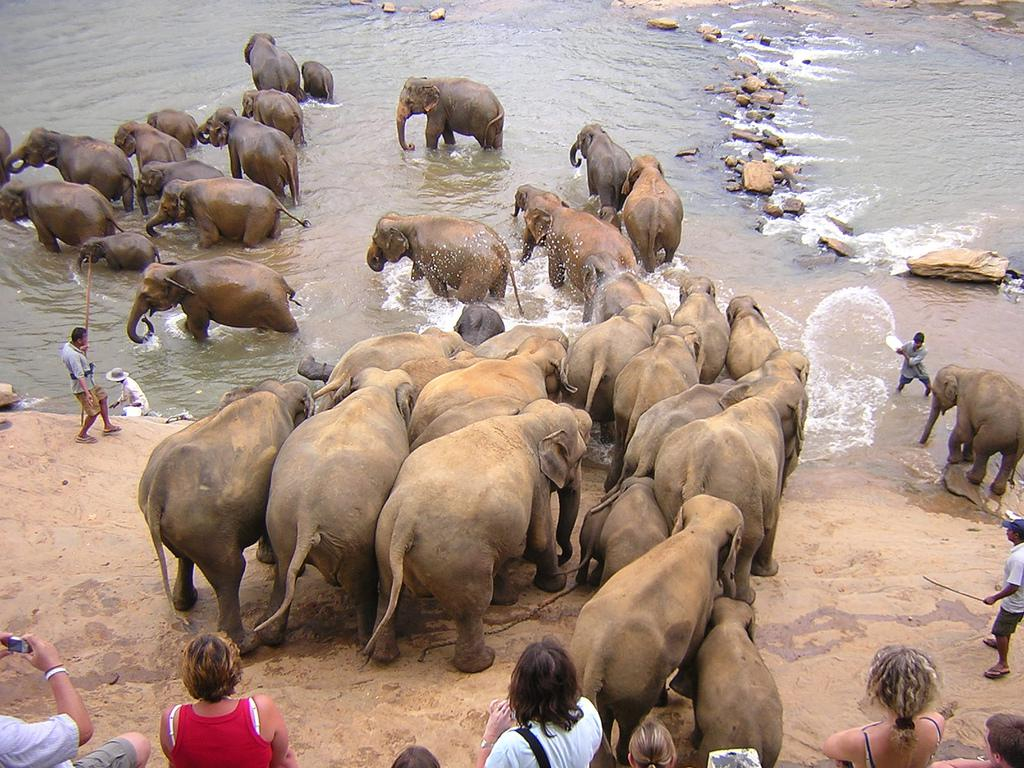Question: who has her bra straps showing?
Choices:
A. The young lady in the white tank top.
B. The girl in the black workout top running on the track.
C. The middle-aged lady wearing  the blue, sleeveless crop top.
D. A woman in a red shirt.
Answer with the letter. Answer: D Question: what direction are the elephants facing?
Choices:
A. They are facing to the left.
B. They are facing to the right.
C. They are facing the same direction.
D. They are facing down.
Answer with the letter. Answer: C Question: what are the people doing?
Choices:
A. Sleeping.
B. Eating.
C. Drawing.
D. Taking pictures.
Answer with the letter. Answer: D Question: why are there elephants on the beach?
Choices:
A. To get cleaned up.
B. To swim.
C. For a beach circus.
D. To eat.
Answer with the letter. Answer: A Question: what color are the elephants?
Choices:
A. Gray.
B. White.
C. Pink.
D. Brown.
Answer with the letter. Answer: D Question: what has mud on their backs?
Choices:
A. Rhinos.
B. Wilder beast.
C. Hippos.
D. Elephants.
Answer with the letter. Answer: D Question: what is happening with the large group of elephants?
Choices:
A. They are drinking.
B. They are sleeping.
C. They are running.
D. They are being herded into water.
Answer with the letter. Answer: D Question: what color tank top is the lady wearing?
Choices:
A. She is wearing a red tank top.
B. She is wearing a blue tank top.
C. She is wearing a green tank top.
D. She is wearing a yellow tank top.
Answer with the letter. Answer: A Question: who has a big stick?
Choices:
A. Man.
B. Woman.
C. Girl.
D. Boy.
Answer with the letter. Answer: A Question: where do the elephants wade?
Choices:
A. Water.
B. The lake.
C. The waterfall.
D. The steam.
Answer with the letter. Answer: A Question: what do the tourists enjoy watching?
Choices:
A. They enjoy watching hippos.
B. They enjoy watching rhinos.
C. They enjoy watching the elephants heading into the water.
D. They enjoy watching monkeys.
Answer with the letter. Answer: C Question: what depth is the water?
Choices:
A. The water is not shallow.
B. Th water is deep.
C. The water is shallow.
D. The water is very deep.
Answer with the letter. Answer: C Question: who huddles together?
Choices:
A. Lions.
B. Elephants.
C. Mircats.
D. Tigers.
Answer with the letter. Answer: B Question: what small living creature is in the herd?
Choices:
A. An ostrich.
B. A small raccoon.
C. Baby elephant.
D. A lost kitten.
Answer with the letter. Answer: C Question: where is the rocky section of water?
Choices:
A. Ahead.
B. To the right.
C. Behind us.
D. To the left.
Answer with the letter. Answer: B Question: how do the elephants look once wet with water?
Choices:
A. Slick.
B. Refreshed and shiny.
C. Dark gray, almost brown.
D. Smooth, instead of wrinkled.
Answer with the letter. Answer: A Question: what is the tourist taking a picture of?
Choices:
A. The tourist is taking a picture of the hippos.
B. The tourist is taking a picture of the elephants.
C. The tourist is taking a picture of the rhinos.
D. The tourist is taking a picture of the monkeys.
Answer with the letter. Answer: B Question: what is white?
Choices:
A. Undergarments.
B. Corset.
C. Bra.
D. Lingerie.
Answer with the letter. Answer: C Question: who has blonde hair?
Choices:
A. Girl.
B. Woman.
C. Baby girl.
D. Lady.
Answer with the letter. Answer: B 